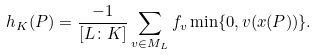Convert formula to latex. <formula><loc_0><loc_0><loc_500><loc_500>h _ { K } ( P ) = \frac { - 1 } { [ L \colon K ] } \sum _ { v \in M _ { L } } f _ { v } \min \{ 0 , v ( x ( P ) ) \} .</formula> 